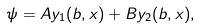Convert formula to latex. <formula><loc_0><loc_0><loc_500><loc_500>\psi = A y _ { 1 } ( b , x ) + B y _ { 2 } ( b , x ) ,</formula> 